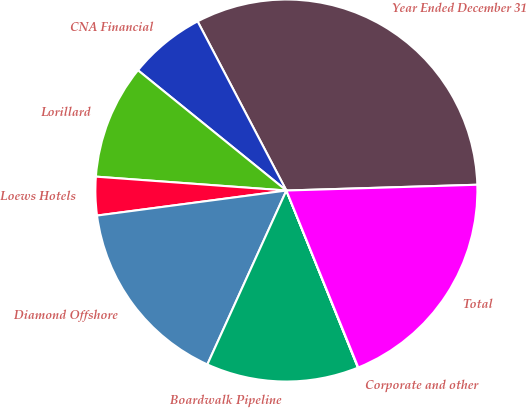Convert chart to OTSL. <chart><loc_0><loc_0><loc_500><loc_500><pie_chart><fcel>Year Ended December 31<fcel>CNA Financial<fcel>Lorillard<fcel>Loews Hotels<fcel>Diamond Offshore<fcel>Boardwalk Pipeline<fcel>Corporate and other<fcel>Total<nl><fcel>32.21%<fcel>6.47%<fcel>9.68%<fcel>3.25%<fcel>16.12%<fcel>12.9%<fcel>0.03%<fcel>19.34%<nl></chart> 